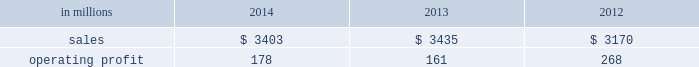Russia and europe .
Average sales price realizations for uncoated freesheet paper decreased in both europe and russia , reflecting weak economic conditions and soft market demand .
In russia , sales prices in rubles increased , but this improvement is masked by the impact of the currency depreciation against the u.s .
Dollar .
Input costs were significantly higher for wood in both europe and russia , partially offset by lower chemical costs .
Planned maintenance downtime costs were $ 11 million lower in 2014 than in 2013 .
Manufacturing and other operating costs were favorable .
Entering 2015 , sales volumes in the first quarter are expected to be seasonally weaker in russia , and about flat in europe .
Average sales price realizations for uncoated freesheet paper are expected to remain steady in europe , but increase in russia .
Input costs should be lower for oil and wood , partially offset by higher chemicals costs .
Indian papers net sales were $ 178 million in 2014 , $ 185 million ( $ 174 million excluding excise duties which were included in net sales in 2013 and prior periods ) in 2013 and $ 185 million ( $ 178 million excluding excise duties ) in 2012 .
Operating profits were $ 8 million ( a loss of $ 12 million excluding a gain related to the resolution of a legal contingency ) in 2014 , a loss of $ 145 million ( a loss of $ 22 million excluding goodwill and trade name impairment charges ) in 2013 and a loss of $ 16 million in 2012 .
Average sales price realizations improved in 2014 compared with 2013 due to the impact of price increases implemented in 2013 .
Sales volumes were flat , reflecting weak economic conditions .
Input costs were higher , primarily for wood .
Operating costs and planned maintenance downtime costs were lower in 2014 .
Looking ahead to the first quarter of 2015 , sales volumes are expected to be seasonally higher .
Average sales price realizations are expected to decrease due to competitive pressures .
Asian printing papers net sales were $ 59 million in 2014 , $ 90 million in 2013 and $ 85 million in 2012 .
Operating profits were $ 0 million in 2014 and $ 1 million in both 2013 and 2012 .
U.s .
Pulp net sales were $ 895 million in 2014 compared with $ 815 million in 2013 and $ 725 million in 2012 .
Operating profits were $ 57 million in 2014 compared with $ 2 million in 2013 and a loss of $ 59 million in 2012 .
Sales volumes in 2014 increased from 2013 for both fluff pulp and market pulp reflecting improved market demand .
Average sales price realizations increased significantly for fluff pulp , while prices for market pulp were also higher .
Input costs for wood and energy were higher .
Operating costs were lower , but planned maintenance downtime costs were $ 1 million higher .
Compared with the fourth quarter of 2014 , sales volumes in the first quarter of 2015 , are expected to decrease for market pulp , but be slightly higher for fluff pulp .
Average sales price realizations are expected to to be stable for fluff pulp and softwood market pulp , while hardwood market pulp prices are expected to improve .
Input costs should be flat .
Planned maintenance downtime costs should be about $ 13 million higher than in the fourth quarter of 2014 .
Consumer packaging demand and pricing for consumer packaging products correlate closely with consumer spending and general economic activity .
In addition to prices and volumes , major factors affecting the profitability of consumer packaging are raw material and energy costs , freight costs , manufacturing efficiency and product mix .
Consumer packaging net sales in 2014 decreased 1% ( 1 % ) from 2013 , but increased 7% ( 7 % ) from 2012 .
Operating profits increased 11% ( 11 % ) from 2013 , but decreased 34% ( 34 % ) from 2012 .
Excluding sheet plant closure costs , costs associated with the permanent shutdown of a paper machine at our augusta , georgia mill and costs related to the sale of the shorewood business , 2014 operating profits were 11% ( 11 % ) lower than in 2013 , and 30% ( 30 % ) lower than in 2012 .
Benefits from higher average sales price realizations and a favorable mix ( $ 60 million ) were offset by lower sales volumes ( $ 11 million ) , higher operating costs ( $ 9 million ) , higher planned maintenance downtime costs ( $ 12 million ) , higher input costs ( $ 43 million ) and higher other costs ( $ 7 million ) .
In addition , operating profits in 2014 include $ 8 million of costs associated with sheet plant closures , while operating profits in 2013 include costs of $ 45 million related to the permanent shutdown of a paper machine at our augusta , georgia mill and $ 2 million of costs associated with the sale of the shorewood business .
Consumer packaging .
North american consumer packaging net sales were $ 2.0 billion in 2014 compared with $ 2.0 billion in 2013 and $ 2.0 billion in 2012 .
Operating profits were $ 92 million ( $ 100 million excluding sheet plant closure costs ) in 2014 compared with $ 63 million ( $ 110 million excluding paper machine shutdown costs and costs related to the sale of the shorewood business ) in 2013 and $ 165 million ( $ 162 million excluding a gain associated with the sale of the shorewood business in 2012 ) .
Coated paperboard sales volumes in 2014 were lower than in 2013 reflecting weaker market demand .
The business took about 41000 tons of market-related downtime in 2014 compared with about 24000 tons in 2013 .
Average sales price realizations increased year- .
What was the consumer packaging profit margin in 2012? 
Computations: (268 / 3170)
Answer: 0.08454. 